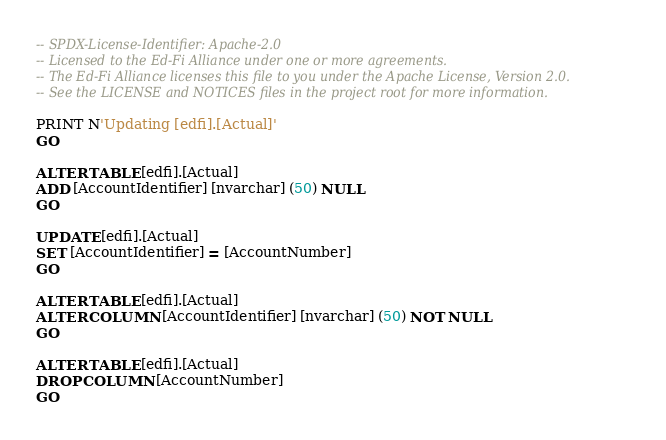Convert code to text. <code><loc_0><loc_0><loc_500><loc_500><_SQL_>-- SPDX-License-Identifier: Apache-2.0
-- Licensed to the Ed-Fi Alliance under one or more agreements.
-- The Ed-Fi Alliance licenses this file to you under the Apache License, Version 2.0.
-- See the LICENSE and NOTICES files in the project root for more information.

PRINT N'Updating [edfi].[Actual]'
GO

ALTER TABLE [edfi].[Actual]
ADD [AccountIdentifier] [nvarchar] (50) NULL
GO

UPDATE [edfi].[Actual]
SET [AccountIdentifier] = [AccountNumber]
GO

ALTER TABLE [edfi].[Actual]
ALTER COLUMN [AccountIdentifier] [nvarchar] (50) NOT NULL
GO

ALTER TABLE [edfi].[Actual]
DROP COLUMN [AccountNumber]
GO
</code> 